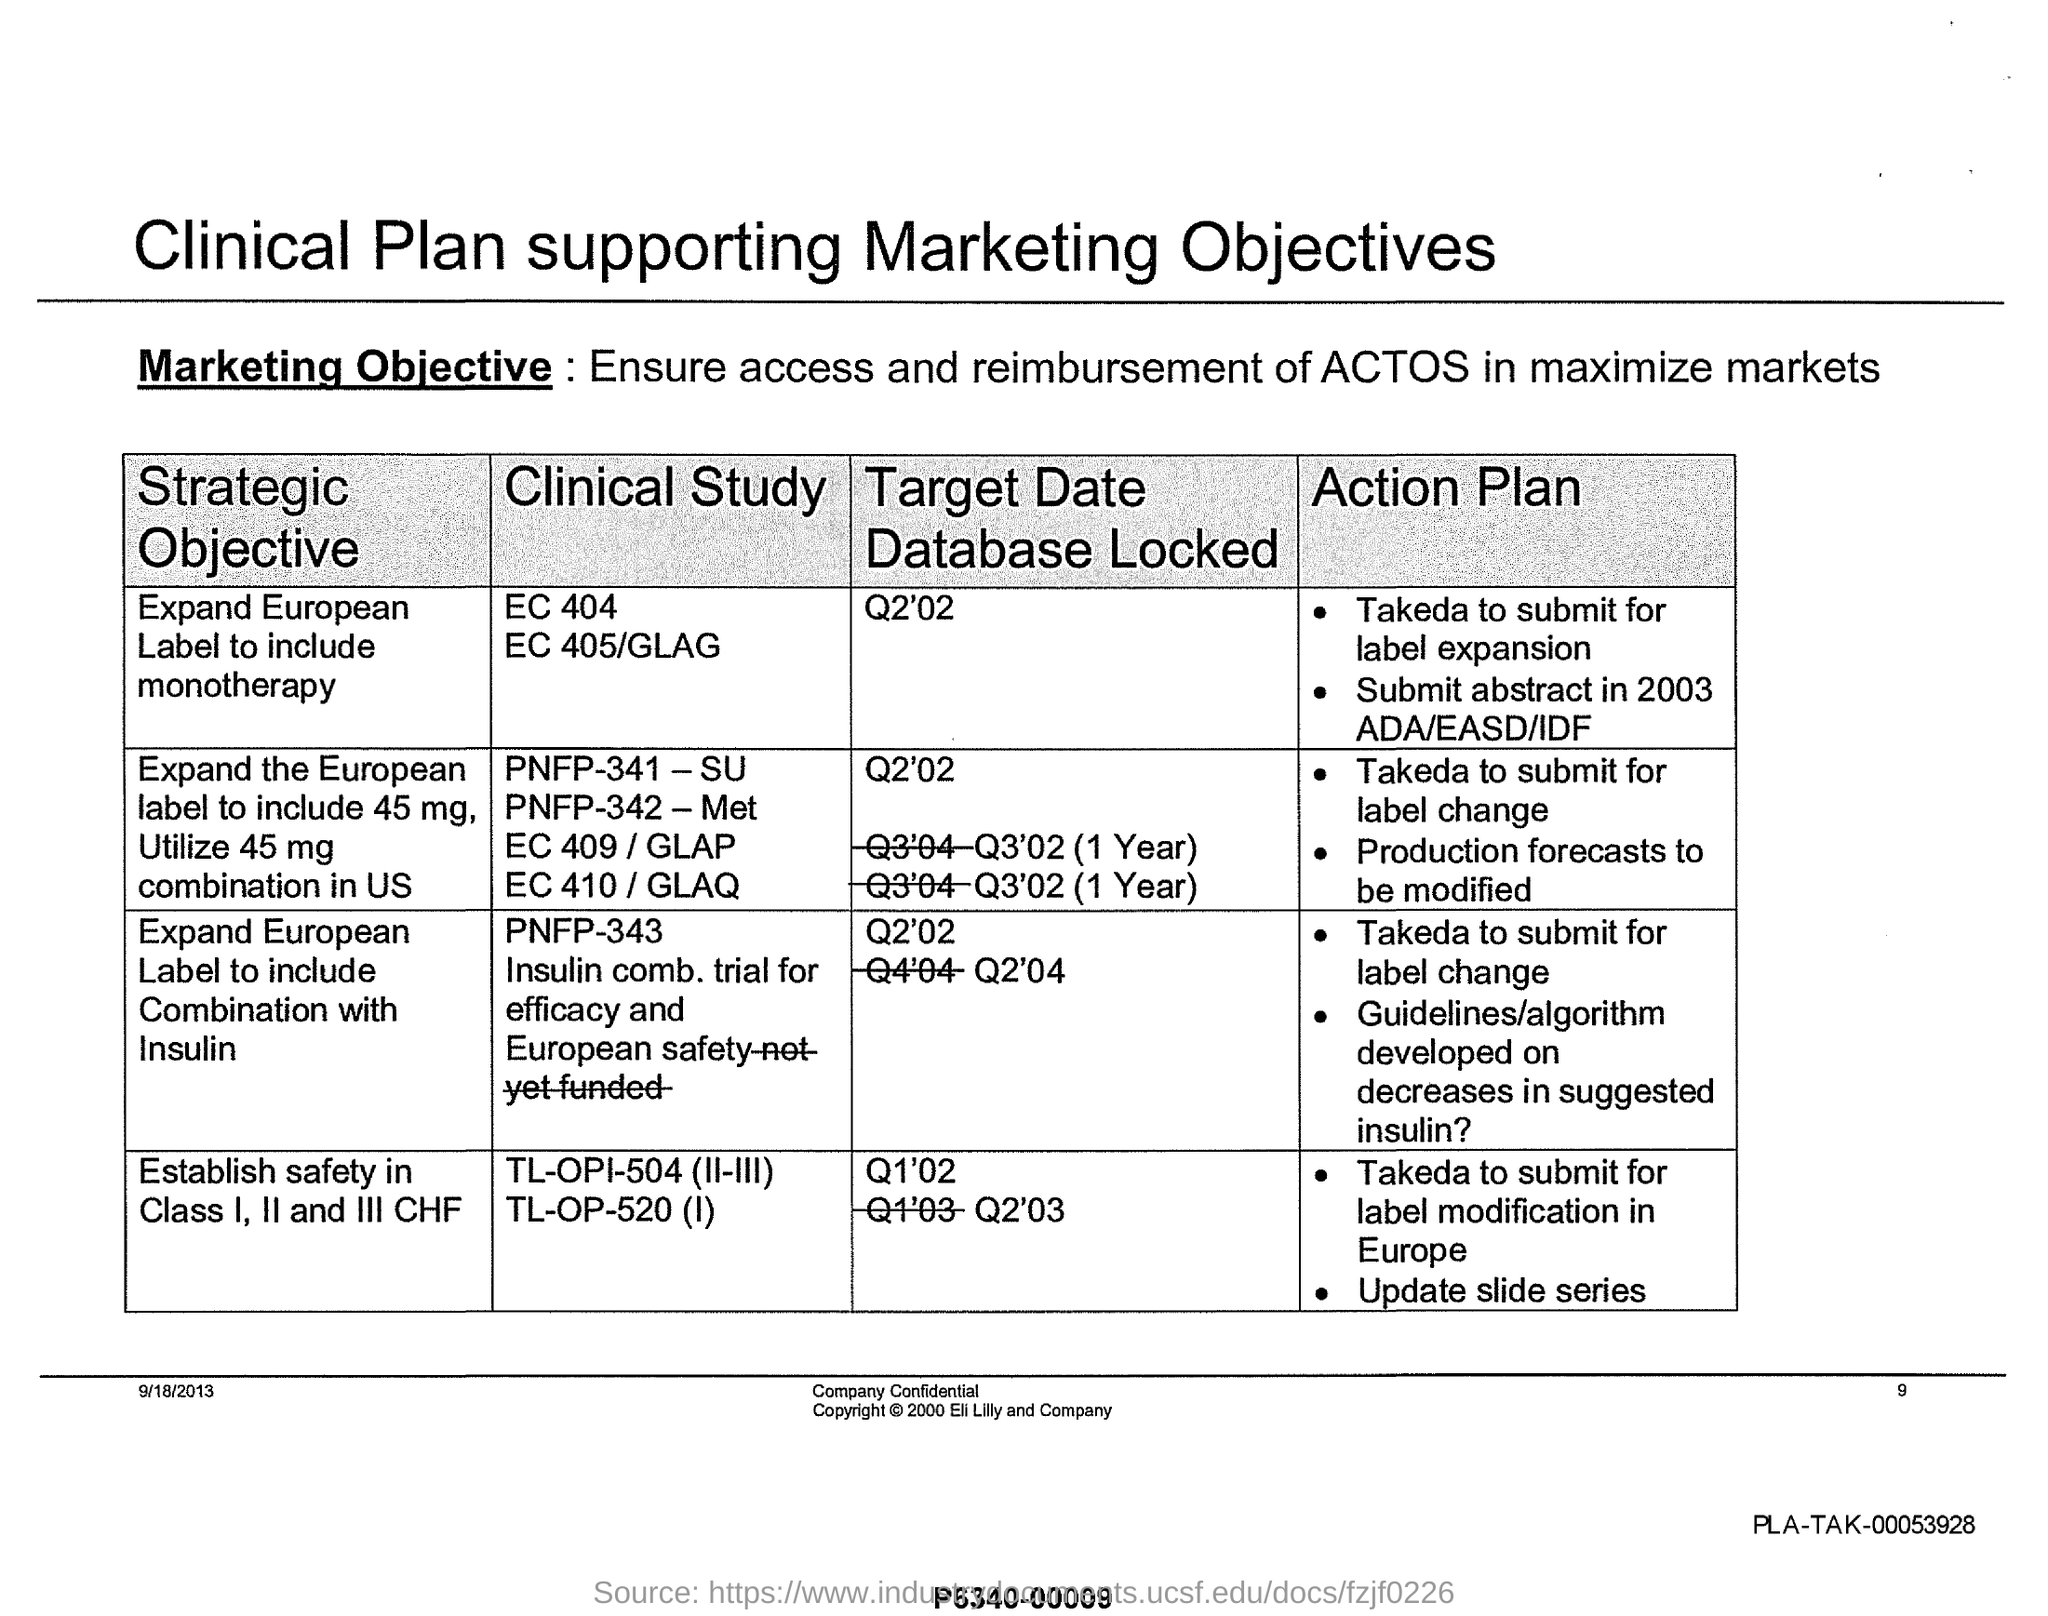What is the page no mentioned in this document?
Provide a succinct answer. 9. What is the date mentioned in this document?
Ensure brevity in your answer.  9/18/2013. What is the marketing objective given in the document?
Your answer should be very brief. Ensure access and reimbursement of ACTOS in maximize markets. 